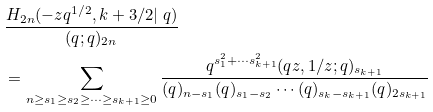Convert formula to latex. <formula><loc_0><loc_0><loc_500><loc_500>& \frac { H _ { 2 n } ( - z q ^ { 1 / 2 } , k + 3 / 2 | \ q ) } { ( q ; q ) _ { 2 n } } \\ & = \sum _ { n \geq s _ { 1 } \geq s _ { 2 } \geq \cdots \geq s _ { k + 1 } \geq 0 } \frac { q ^ { s _ { 1 } ^ { 2 } + \cdots s _ { k + 1 } ^ { 2 } } ( q z , 1 / z ; q ) _ { s _ { k + 1 } } } { ( q ) _ { n - s _ { 1 } } ( q ) _ { s _ { 1 } - s _ { 2 } } \cdots ( q ) _ { s _ { k } - s _ { k + 1 } } ( q ) _ { 2 s _ { k + 1 } } }</formula> 